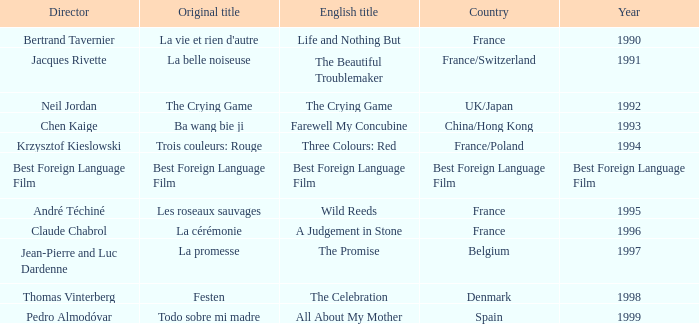Which Country is listed for the Director Thomas Vinterberg? Denmark. 